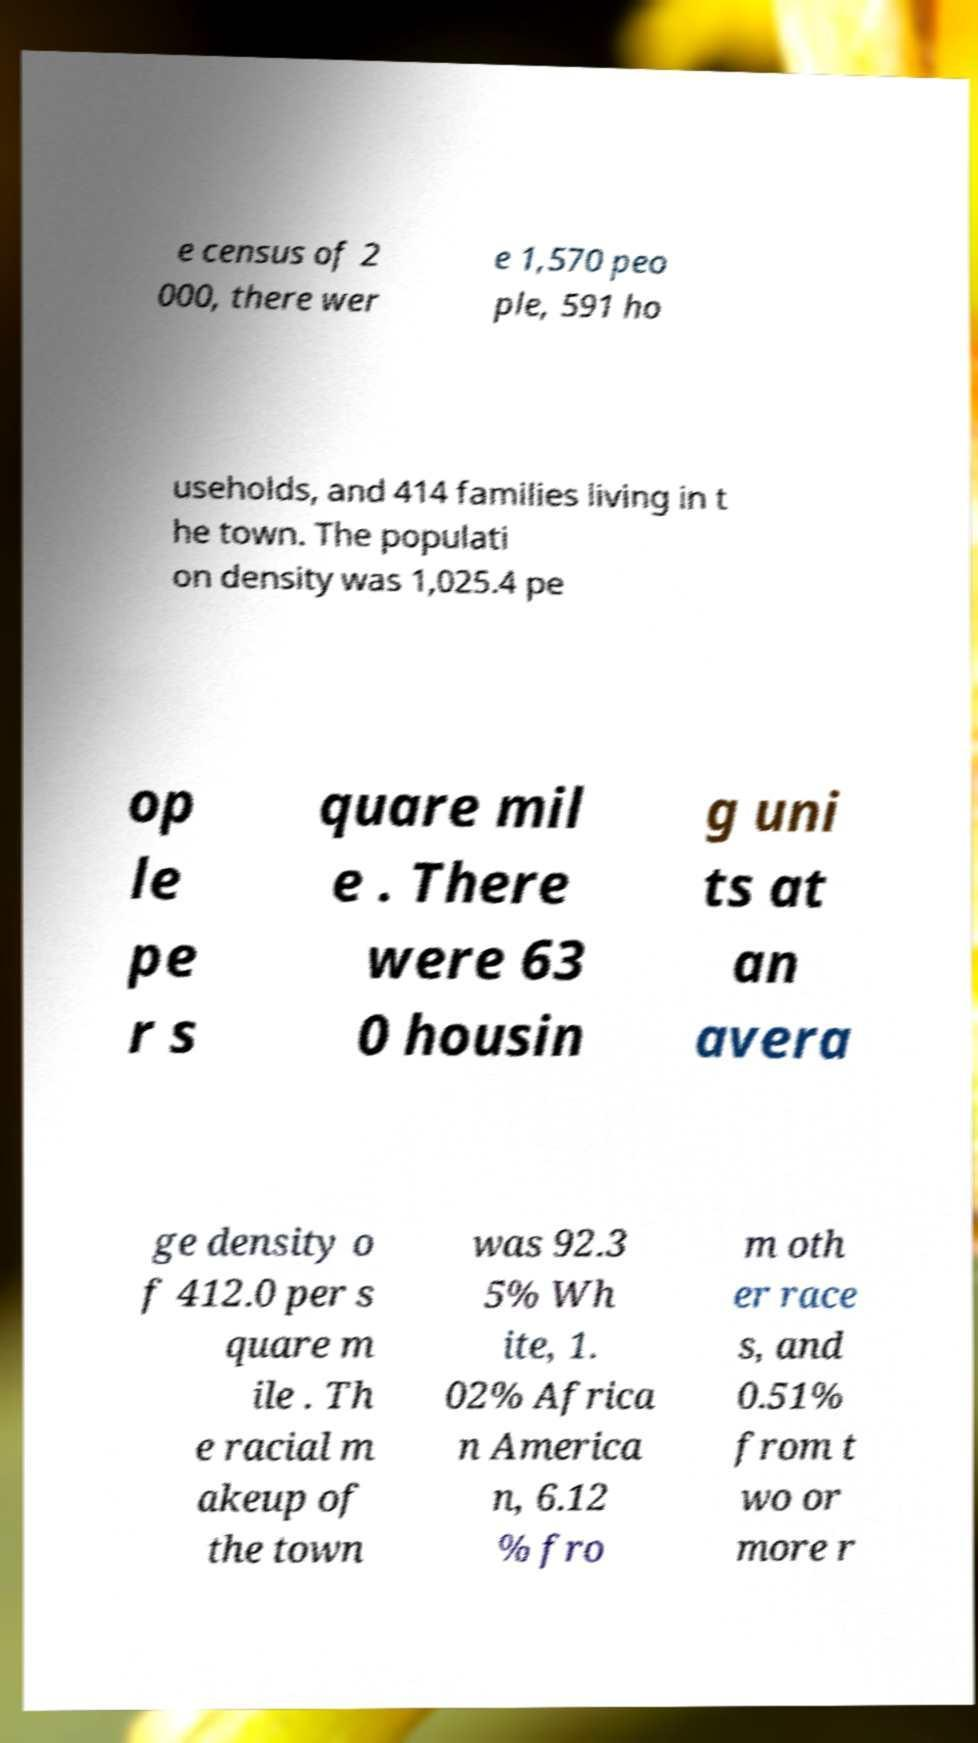Can you read and provide the text displayed in the image?This photo seems to have some interesting text. Can you extract and type it out for me? e census of 2 000, there wer e 1,570 peo ple, 591 ho useholds, and 414 families living in t he town. The populati on density was 1,025.4 pe op le pe r s quare mil e . There were 63 0 housin g uni ts at an avera ge density o f 412.0 per s quare m ile . Th e racial m akeup of the town was 92.3 5% Wh ite, 1. 02% Africa n America n, 6.12 % fro m oth er race s, and 0.51% from t wo or more r 